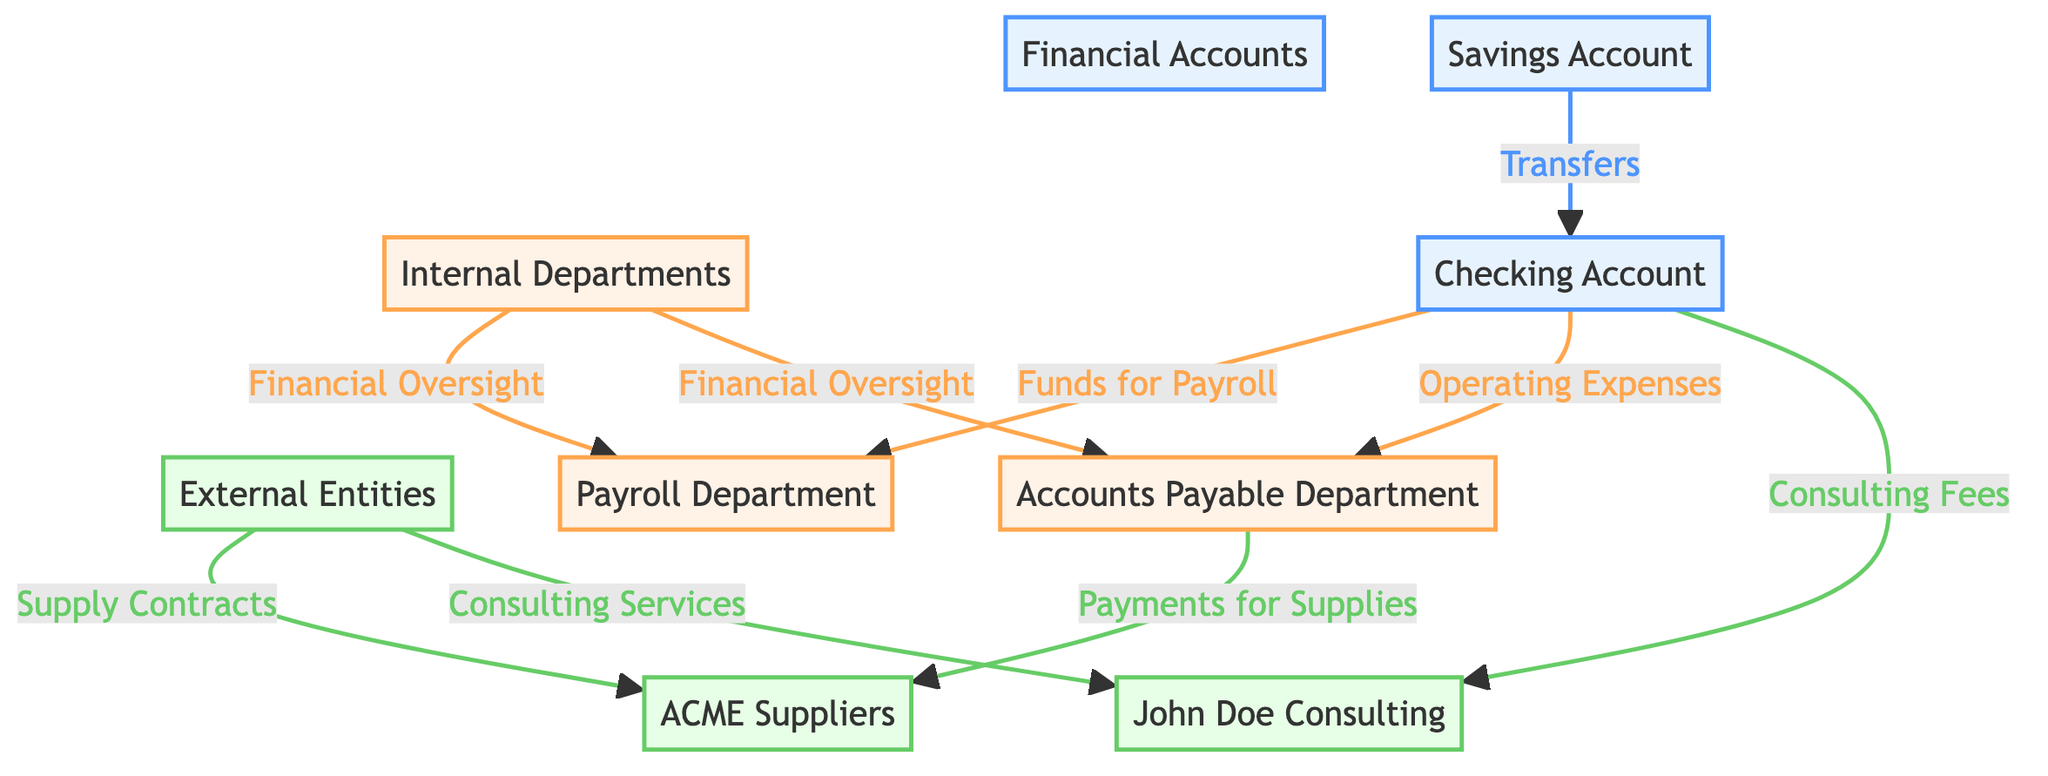What is the total number of financial accounts in the diagram? There are two financial accounts depicted: the Checking Account and the Savings Account.
Answer: 2 Which department oversees both the Payroll Department and the Accounts Payable Department? The Internal Departments node indicates that there is an overall financial oversight for both the Payroll Department and the Accounts Payable Department.
Answer: Internal Departments What type of relationship connects the Checking Account to the Payroll Department? The relationship is labeled as "Funds for Payroll," indicating that funds are transferred from the Checking Account to the Payroll Department for payroll purposes.
Answer: Funds for Payroll How many external entities are represented in the diagram? The diagram lists two external entities: ACME Suppliers and John Doe Consulting.
Answer: 2 What payment type is made from the Accounts Payable Department to the ACME Suppliers? The connection from the Accounts Payable Department to ACME Suppliers is labeled as "Payments for Supplies," showing the nature of the transaction.
Answer: Payments for Supplies Which account does the Accounts Payable Department utilize to pay for supplies? The flow from the Accounts Payable Department to ACME Suppliers indicates that the Payments for Supplies are made using the Checking Account, which funds all department activities.
Answer: Checking Account What role does the Consulting Services relationship play in the diagram? The relationship is indicated as a connection from John Doe Consulting to the External Entities, showing that they provide consulting services to the organization.
Answer: Consulting Services Which account funds the operating expenses for the Accounts Payable Department? The flow from the Checking Account indicates that it is the source of funds used for operating expenses for the Accounts Payable Department.
Answer: Checking Account What is the relationship type shown between Internal Departments and Payroll Department? The diagram indicates a financial oversight relationship, emphasizing the internal controls in place regarding payroll activities.
Answer: Financial Oversight 